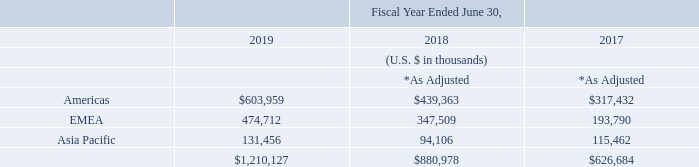Disaggregated revenue
The Group’s revenues by geographic region based on end-users who purchased our products or services are as follows:
Revenues from the United States totaled approximately $529 million, $386 million, and $281 million for the fiscal years ended 2019, 2018, and 2017, respectively. Revenues from our country of domicile, the United Kingdom, totaled approximately $86 million, $63 million, and $46 million for the fiscal years ended 2019, 2018, and 2017, respectively. No one customer has accounted for more than 10% of revenue for the fiscal years ended 2019, 2018, and 2017.
What are the revenue amounts from the United States for fiscal years ended 2017, 2018 and 2019 respectively? $281 million, $386 million, $529 million. What are the revenue amounts from the United Kingdom for fiscal years ended 2017, 2018 and 2019 respectively? $46 million, $63 million, $86 million. What is the revenue amount from Asia Pacific for fiscal year ended 2019?
Answer scale should be: thousand. 131,456. In fiscal year ended 2019, how many geographic regions have more than $500,000 thousand of revenues? Americas
Answer: 1. What is the percentage constitution of the revenues from Asia Pacific among the total revenues in fiscal year ended 2017?
Answer scale should be: percent. 115,462/626,684
Answer: 18.42. What is the difference in the revenues from Asia Pacific between fiscal years ended 2018 and 2019?
Answer scale should be: thousand. 131,456-94,106
Answer: 37350. 